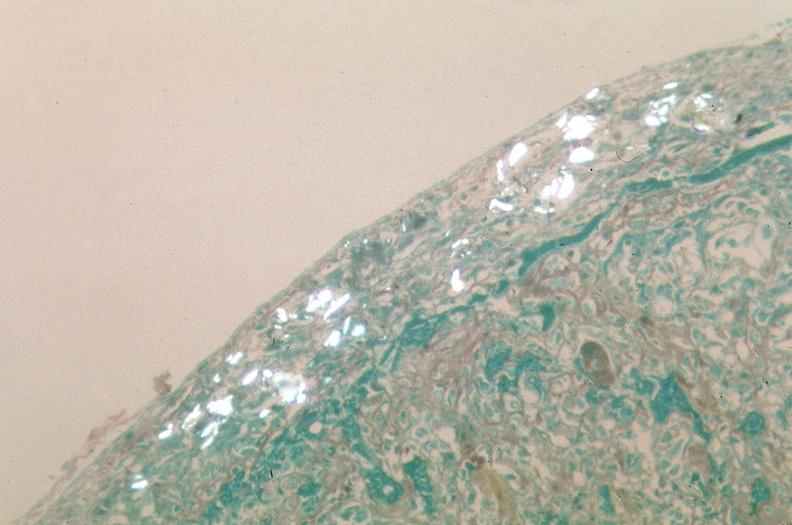where is this?
Answer the question using a single word or phrase. Lung 